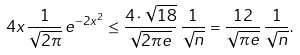Convert formula to latex. <formula><loc_0><loc_0><loc_500><loc_500>4 x \, \frac { 1 } { \sqrt { 2 \pi } } \, e ^ { - 2 x ^ { 2 } } \leq \frac { 4 \cdot \sqrt { 1 8 } } { \sqrt { 2 \pi e } } \, \frac { 1 } { \sqrt { n } } = \frac { 1 2 } { \sqrt { \pi e } } \, \frac { 1 } { \sqrt { n } } .</formula> 